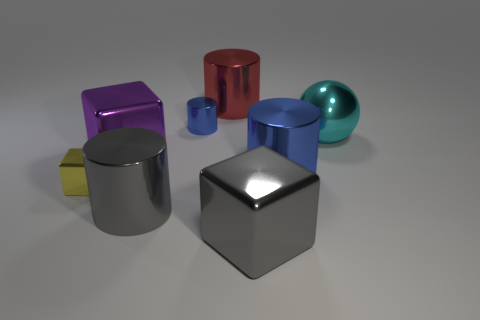There is a gray thing that is the same shape as the red shiny object; what is it made of?
Make the answer very short. Metal. There is a metallic cylinder behind the tiny thing that is on the right side of the small yellow block; how big is it?
Your answer should be compact. Large. What is the large thing that is behind the big ball made of?
Offer a terse response. Metal. What is the size of the red object that is the same material as the big cyan object?
Give a very brief answer. Large. What number of gray objects are the same shape as the big purple shiny object?
Your answer should be compact. 1. There is a purple metallic object; does it have the same shape as the big metal object that is to the right of the big blue shiny cylinder?
Your answer should be very brief. No. What shape is the metal object that is the same color as the tiny cylinder?
Your answer should be very brief. Cylinder. Are there any cyan balls made of the same material as the red cylinder?
Make the answer very short. Yes. Are there any other things that are the same material as the red cylinder?
Make the answer very short. Yes. There is a big cube that is behind the blue object that is in front of the large purple object; what is it made of?
Keep it short and to the point. Metal. 